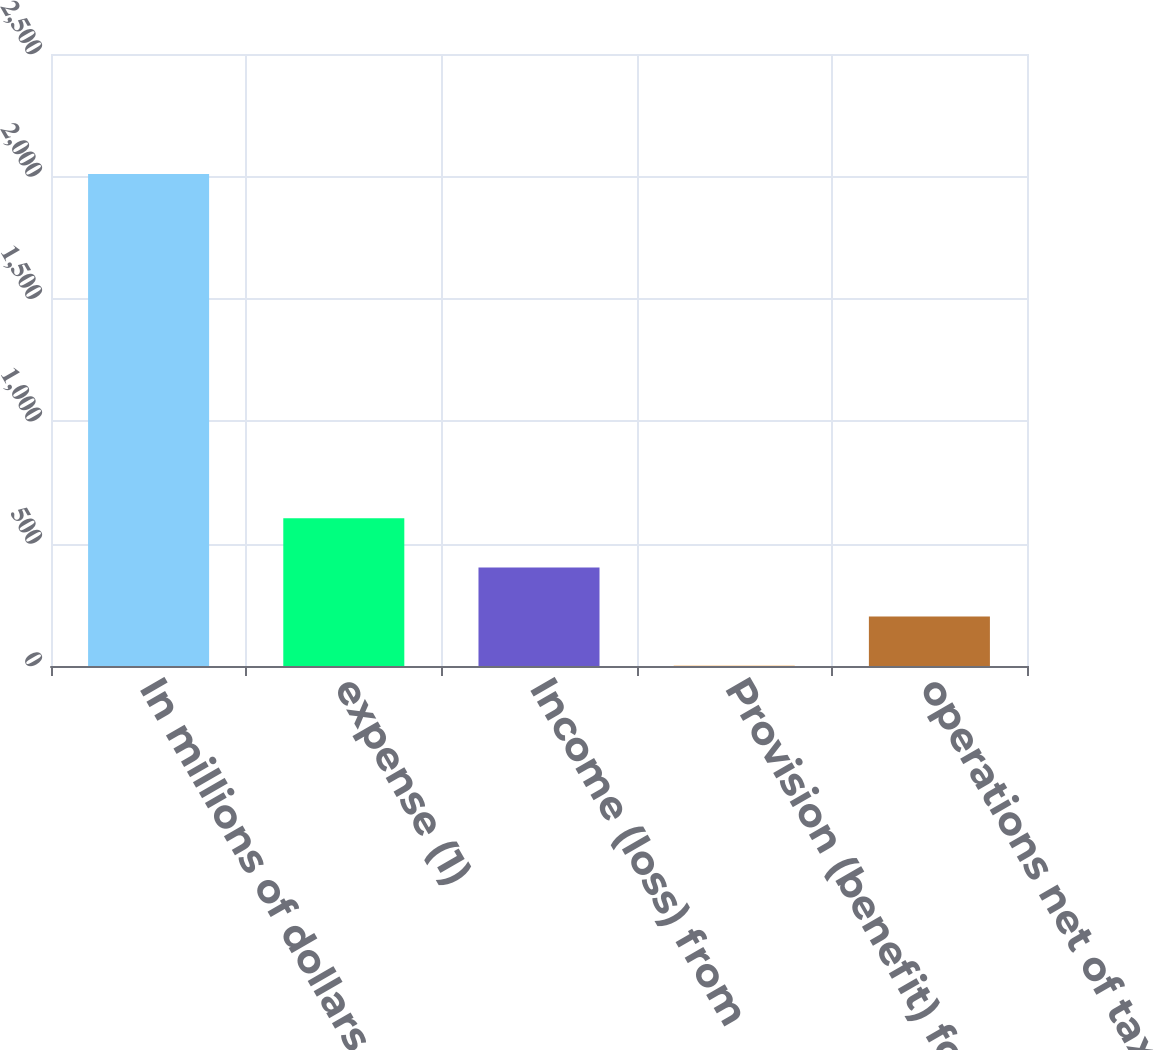Convert chart to OTSL. <chart><loc_0><loc_0><loc_500><loc_500><bar_chart><fcel>In millions of dollars<fcel>expense (1)<fcel>Income (loss) from<fcel>Provision (benefit) for income<fcel>operations net of taxes<nl><fcel>2010<fcel>603.7<fcel>402.8<fcel>1<fcel>201.9<nl></chart> 